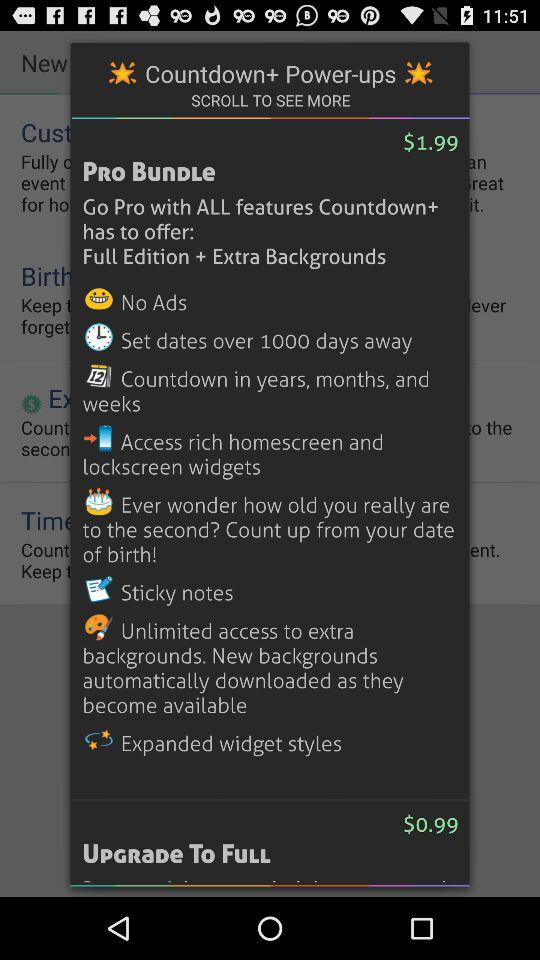What is the price for a full upgrade? The price for a full upgrade is $0.99. 